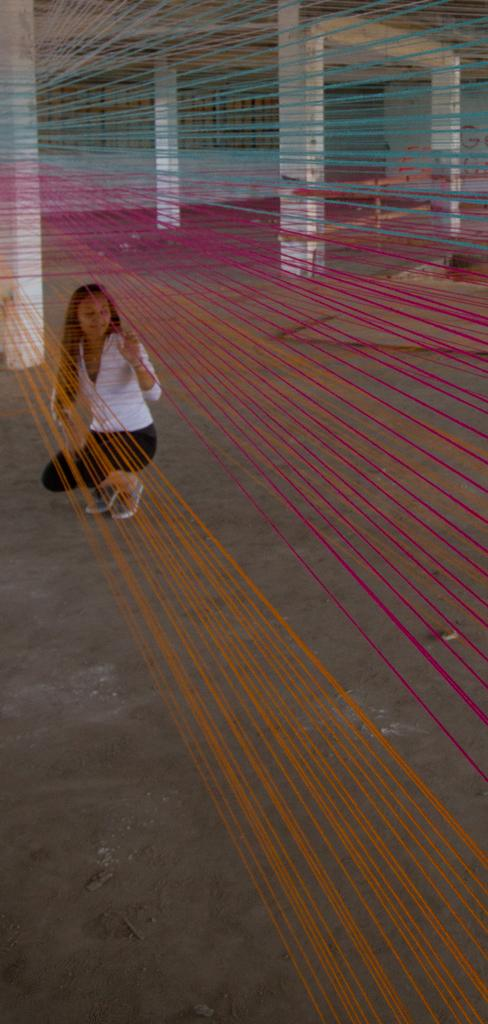What can be seen in the image that is related to textiles or crafts? There are tied threads in the image, and a woman is on the ground holding the threads. What type of structure is visible in the image? There are pillars, a wall, and a roof in the image. Can you tell me how many verses are written on the wall in the image? There are no verses written on the wall in the image; it only shows a woman holding tied threads and a structure with pillars, a wall, and a roof. What type of tool is used to cut the threads in the image? There is no tool shown in the image for cutting the threads; the woman is simply holding them. 